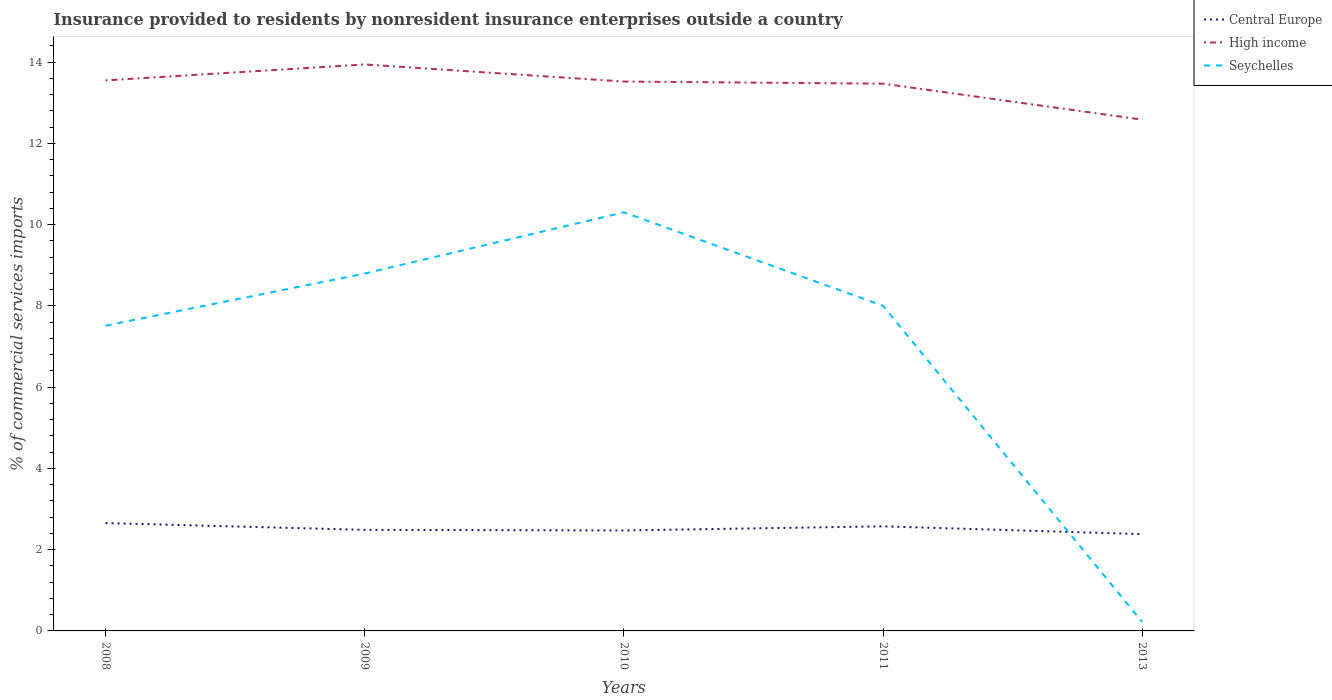Does the line corresponding to High income intersect with the line corresponding to Seychelles?
Your response must be concise. No. Across all years, what is the maximum Insurance provided to residents in Seychelles?
Give a very brief answer. 0.22. In which year was the Insurance provided to residents in Seychelles maximum?
Provide a succinct answer. 2013. What is the total Insurance provided to residents in Central Europe in the graph?
Ensure brevity in your answer.  0.1. What is the difference between the highest and the second highest Insurance provided to residents in Central Europe?
Your response must be concise. 0.27. What is the difference between the highest and the lowest Insurance provided to residents in High income?
Your answer should be compact. 4. How many lines are there?
Your answer should be very brief. 3. How many legend labels are there?
Your answer should be compact. 3. How are the legend labels stacked?
Provide a short and direct response. Vertical. What is the title of the graph?
Offer a terse response. Insurance provided to residents by nonresident insurance enterprises outside a country. What is the label or title of the Y-axis?
Your response must be concise. % of commercial services imports. What is the % of commercial services imports of Central Europe in 2008?
Your answer should be compact. 2.65. What is the % of commercial services imports of High income in 2008?
Make the answer very short. 13.55. What is the % of commercial services imports of Seychelles in 2008?
Offer a terse response. 7.51. What is the % of commercial services imports of Central Europe in 2009?
Offer a very short reply. 2.49. What is the % of commercial services imports of High income in 2009?
Offer a very short reply. 13.94. What is the % of commercial services imports of Seychelles in 2009?
Provide a succinct answer. 8.8. What is the % of commercial services imports of Central Europe in 2010?
Your answer should be compact. 2.47. What is the % of commercial services imports in High income in 2010?
Offer a very short reply. 13.52. What is the % of commercial services imports in Seychelles in 2010?
Your answer should be compact. 10.3. What is the % of commercial services imports in Central Europe in 2011?
Provide a short and direct response. 2.57. What is the % of commercial services imports of High income in 2011?
Provide a succinct answer. 13.47. What is the % of commercial services imports of Seychelles in 2011?
Your response must be concise. 8. What is the % of commercial services imports in Central Europe in 2013?
Ensure brevity in your answer.  2.38. What is the % of commercial services imports in High income in 2013?
Make the answer very short. 12.58. What is the % of commercial services imports in Seychelles in 2013?
Provide a short and direct response. 0.22. Across all years, what is the maximum % of commercial services imports of Central Europe?
Your answer should be compact. 2.65. Across all years, what is the maximum % of commercial services imports of High income?
Make the answer very short. 13.94. Across all years, what is the maximum % of commercial services imports in Seychelles?
Make the answer very short. 10.3. Across all years, what is the minimum % of commercial services imports in Central Europe?
Offer a very short reply. 2.38. Across all years, what is the minimum % of commercial services imports in High income?
Offer a terse response. 12.58. Across all years, what is the minimum % of commercial services imports in Seychelles?
Provide a succinct answer. 0.22. What is the total % of commercial services imports in Central Europe in the graph?
Make the answer very short. 12.57. What is the total % of commercial services imports of High income in the graph?
Keep it short and to the point. 67.06. What is the total % of commercial services imports of Seychelles in the graph?
Ensure brevity in your answer.  34.83. What is the difference between the % of commercial services imports of Central Europe in 2008 and that in 2009?
Provide a succinct answer. 0.17. What is the difference between the % of commercial services imports of High income in 2008 and that in 2009?
Keep it short and to the point. -0.39. What is the difference between the % of commercial services imports in Seychelles in 2008 and that in 2009?
Your answer should be very brief. -1.28. What is the difference between the % of commercial services imports of Central Europe in 2008 and that in 2010?
Ensure brevity in your answer.  0.18. What is the difference between the % of commercial services imports of High income in 2008 and that in 2010?
Keep it short and to the point. 0.03. What is the difference between the % of commercial services imports in Seychelles in 2008 and that in 2010?
Keep it short and to the point. -2.79. What is the difference between the % of commercial services imports of Central Europe in 2008 and that in 2011?
Your response must be concise. 0.08. What is the difference between the % of commercial services imports in High income in 2008 and that in 2011?
Provide a short and direct response. 0.08. What is the difference between the % of commercial services imports of Seychelles in 2008 and that in 2011?
Keep it short and to the point. -0.49. What is the difference between the % of commercial services imports of Central Europe in 2008 and that in 2013?
Provide a succinct answer. 0.27. What is the difference between the % of commercial services imports of High income in 2008 and that in 2013?
Ensure brevity in your answer.  0.97. What is the difference between the % of commercial services imports in Seychelles in 2008 and that in 2013?
Offer a very short reply. 7.29. What is the difference between the % of commercial services imports in Central Europe in 2009 and that in 2010?
Ensure brevity in your answer.  0.01. What is the difference between the % of commercial services imports of High income in 2009 and that in 2010?
Your response must be concise. 0.42. What is the difference between the % of commercial services imports in Seychelles in 2009 and that in 2010?
Your response must be concise. -1.51. What is the difference between the % of commercial services imports in Central Europe in 2009 and that in 2011?
Keep it short and to the point. -0.09. What is the difference between the % of commercial services imports of High income in 2009 and that in 2011?
Your response must be concise. 0.47. What is the difference between the % of commercial services imports in Seychelles in 2009 and that in 2011?
Give a very brief answer. 0.79. What is the difference between the % of commercial services imports of Central Europe in 2009 and that in 2013?
Offer a terse response. 0.1. What is the difference between the % of commercial services imports in High income in 2009 and that in 2013?
Your response must be concise. 1.36. What is the difference between the % of commercial services imports of Seychelles in 2009 and that in 2013?
Your answer should be very brief. 8.57. What is the difference between the % of commercial services imports of Central Europe in 2010 and that in 2011?
Your answer should be very brief. -0.1. What is the difference between the % of commercial services imports in High income in 2010 and that in 2011?
Provide a short and direct response. 0.05. What is the difference between the % of commercial services imports of Seychelles in 2010 and that in 2011?
Give a very brief answer. 2.3. What is the difference between the % of commercial services imports in Central Europe in 2010 and that in 2013?
Offer a terse response. 0.09. What is the difference between the % of commercial services imports of Seychelles in 2010 and that in 2013?
Give a very brief answer. 10.08. What is the difference between the % of commercial services imports of Central Europe in 2011 and that in 2013?
Provide a succinct answer. 0.19. What is the difference between the % of commercial services imports of High income in 2011 and that in 2013?
Your response must be concise. 0.88. What is the difference between the % of commercial services imports of Seychelles in 2011 and that in 2013?
Keep it short and to the point. 7.78. What is the difference between the % of commercial services imports in Central Europe in 2008 and the % of commercial services imports in High income in 2009?
Ensure brevity in your answer.  -11.29. What is the difference between the % of commercial services imports in Central Europe in 2008 and the % of commercial services imports in Seychelles in 2009?
Your answer should be very brief. -6.14. What is the difference between the % of commercial services imports in High income in 2008 and the % of commercial services imports in Seychelles in 2009?
Keep it short and to the point. 4.75. What is the difference between the % of commercial services imports in Central Europe in 2008 and the % of commercial services imports in High income in 2010?
Offer a very short reply. -10.87. What is the difference between the % of commercial services imports of Central Europe in 2008 and the % of commercial services imports of Seychelles in 2010?
Offer a terse response. -7.65. What is the difference between the % of commercial services imports of High income in 2008 and the % of commercial services imports of Seychelles in 2010?
Give a very brief answer. 3.25. What is the difference between the % of commercial services imports of Central Europe in 2008 and the % of commercial services imports of High income in 2011?
Provide a succinct answer. -10.81. What is the difference between the % of commercial services imports of Central Europe in 2008 and the % of commercial services imports of Seychelles in 2011?
Your response must be concise. -5.35. What is the difference between the % of commercial services imports in High income in 2008 and the % of commercial services imports in Seychelles in 2011?
Keep it short and to the point. 5.55. What is the difference between the % of commercial services imports in Central Europe in 2008 and the % of commercial services imports in High income in 2013?
Provide a succinct answer. -9.93. What is the difference between the % of commercial services imports of Central Europe in 2008 and the % of commercial services imports of Seychelles in 2013?
Offer a terse response. 2.43. What is the difference between the % of commercial services imports in High income in 2008 and the % of commercial services imports in Seychelles in 2013?
Ensure brevity in your answer.  13.33. What is the difference between the % of commercial services imports of Central Europe in 2009 and the % of commercial services imports of High income in 2010?
Make the answer very short. -11.03. What is the difference between the % of commercial services imports of Central Europe in 2009 and the % of commercial services imports of Seychelles in 2010?
Your response must be concise. -7.81. What is the difference between the % of commercial services imports in High income in 2009 and the % of commercial services imports in Seychelles in 2010?
Your response must be concise. 3.64. What is the difference between the % of commercial services imports in Central Europe in 2009 and the % of commercial services imports in High income in 2011?
Ensure brevity in your answer.  -10.98. What is the difference between the % of commercial services imports of Central Europe in 2009 and the % of commercial services imports of Seychelles in 2011?
Make the answer very short. -5.51. What is the difference between the % of commercial services imports in High income in 2009 and the % of commercial services imports in Seychelles in 2011?
Offer a very short reply. 5.94. What is the difference between the % of commercial services imports in Central Europe in 2009 and the % of commercial services imports in High income in 2013?
Offer a very short reply. -10.1. What is the difference between the % of commercial services imports of Central Europe in 2009 and the % of commercial services imports of Seychelles in 2013?
Ensure brevity in your answer.  2.27. What is the difference between the % of commercial services imports in High income in 2009 and the % of commercial services imports in Seychelles in 2013?
Provide a succinct answer. 13.72. What is the difference between the % of commercial services imports in Central Europe in 2010 and the % of commercial services imports in High income in 2011?
Your response must be concise. -11. What is the difference between the % of commercial services imports in Central Europe in 2010 and the % of commercial services imports in Seychelles in 2011?
Your answer should be compact. -5.53. What is the difference between the % of commercial services imports of High income in 2010 and the % of commercial services imports of Seychelles in 2011?
Offer a very short reply. 5.52. What is the difference between the % of commercial services imports in Central Europe in 2010 and the % of commercial services imports in High income in 2013?
Provide a succinct answer. -10.11. What is the difference between the % of commercial services imports of Central Europe in 2010 and the % of commercial services imports of Seychelles in 2013?
Your answer should be very brief. 2.25. What is the difference between the % of commercial services imports of High income in 2010 and the % of commercial services imports of Seychelles in 2013?
Your answer should be compact. 13.3. What is the difference between the % of commercial services imports in Central Europe in 2011 and the % of commercial services imports in High income in 2013?
Your answer should be very brief. -10.01. What is the difference between the % of commercial services imports of Central Europe in 2011 and the % of commercial services imports of Seychelles in 2013?
Offer a very short reply. 2.35. What is the difference between the % of commercial services imports of High income in 2011 and the % of commercial services imports of Seychelles in 2013?
Offer a terse response. 13.25. What is the average % of commercial services imports in Central Europe per year?
Your response must be concise. 2.51. What is the average % of commercial services imports of High income per year?
Your answer should be compact. 13.41. What is the average % of commercial services imports in Seychelles per year?
Keep it short and to the point. 6.97. In the year 2008, what is the difference between the % of commercial services imports in Central Europe and % of commercial services imports in High income?
Give a very brief answer. -10.89. In the year 2008, what is the difference between the % of commercial services imports in Central Europe and % of commercial services imports in Seychelles?
Your answer should be compact. -4.86. In the year 2008, what is the difference between the % of commercial services imports of High income and % of commercial services imports of Seychelles?
Make the answer very short. 6.04. In the year 2009, what is the difference between the % of commercial services imports of Central Europe and % of commercial services imports of High income?
Your response must be concise. -11.45. In the year 2009, what is the difference between the % of commercial services imports in Central Europe and % of commercial services imports in Seychelles?
Keep it short and to the point. -6.31. In the year 2009, what is the difference between the % of commercial services imports of High income and % of commercial services imports of Seychelles?
Your answer should be very brief. 5.15. In the year 2010, what is the difference between the % of commercial services imports of Central Europe and % of commercial services imports of High income?
Offer a terse response. -11.05. In the year 2010, what is the difference between the % of commercial services imports of Central Europe and % of commercial services imports of Seychelles?
Ensure brevity in your answer.  -7.83. In the year 2010, what is the difference between the % of commercial services imports in High income and % of commercial services imports in Seychelles?
Your answer should be very brief. 3.22. In the year 2011, what is the difference between the % of commercial services imports of Central Europe and % of commercial services imports of High income?
Give a very brief answer. -10.89. In the year 2011, what is the difference between the % of commercial services imports in Central Europe and % of commercial services imports in Seychelles?
Offer a very short reply. -5.43. In the year 2011, what is the difference between the % of commercial services imports in High income and % of commercial services imports in Seychelles?
Keep it short and to the point. 5.47. In the year 2013, what is the difference between the % of commercial services imports of Central Europe and % of commercial services imports of High income?
Offer a terse response. -10.2. In the year 2013, what is the difference between the % of commercial services imports in Central Europe and % of commercial services imports in Seychelles?
Give a very brief answer. 2.16. In the year 2013, what is the difference between the % of commercial services imports of High income and % of commercial services imports of Seychelles?
Offer a very short reply. 12.36. What is the ratio of the % of commercial services imports of Central Europe in 2008 to that in 2009?
Provide a short and direct response. 1.07. What is the ratio of the % of commercial services imports in High income in 2008 to that in 2009?
Your answer should be compact. 0.97. What is the ratio of the % of commercial services imports of Seychelles in 2008 to that in 2009?
Your answer should be compact. 0.85. What is the ratio of the % of commercial services imports of Central Europe in 2008 to that in 2010?
Offer a very short reply. 1.07. What is the ratio of the % of commercial services imports in High income in 2008 to that in 2010?
Your response must be concise. 1. What is the ratio of the % of commercial services imports in Seychelles in 2008 to that in 2010?
Provide a short and direct response. 0.73. What is the ratio of the % of commercial services imports in Central Europe in 2008 to that in 2011?
Provide a short and direct response. 1.03. What is the ratio of the % of commercial services imports in Seychelles in 2008 to that in 2011?
Provide a succinct answer. 0.94. What is the ratio of the % of commercial services imports in Central Europe in 2008 to that in 2013?
Your answer should be compact. 1.11. What is the ratio of the % of commercial services imports in High income in 2008 to that in 2013?
Your answer should be compact. 1.08. What is the ratio of the % of commercial services imports of Seychelles in 2008 to that in 2013?
Offer a terse response. 34.03. What is the ratio of the % of commercial services imports in Central Europe in 2009 to that in 2010?
Give a very brief answer. 1.01. What is the ratio of the % of commercial services imports of High income in 2009 to that in 2010?
Your response must be concise. 1.03. What is the ratio of the % of commercial services imports in Seychelles in 2009 to that in 2010?
Offer a terse response. 0.85. What is the ratio of the % of commercial services imports of Central Europe in 2009 to that in 2011?
Offer a very short reply. 0.97. What is the ratio of the % of commercial services imports in High income in 2009 to that in 2011?
Ensure brevity in your answer.  1.04. What is the ratio of the % of commercial services imports of Seychelles in 2009 to that in 2011?
Offer a terse response. 1.1. What is the ratio of the % of commercial services imports of Central Europe in 2009 to that in 2013?
Keep it short and to the point. 1.04. What is the ratio of the % of commercial services imports in High income in 2009 to that in 2013?
Your response must be concise. 1.11. What is the ratio of the % of commercial services imports in Seychelles in 2009 to that in 2013?
Your answer should be compact. 39.84. What is the ratio of the % of commercial services imports in Central Europe in 2010 to that in 2011?
Your answer should be very brief. 0.96. What is the ratio of the % of commercial services imports of High income in 2010 to that in 2011?
Your answer should be very brief. 1. What is the ratio of the % of commercial services imports in Seychelles in 2010 to that in 2011?
Give a very brief answer. 1.29. What is the ratio of the % of commercial services imports of Central Europe in 2010 to that in 2013?
Give a very brief answer. 1.04. What is the ratio of the % of commercial services imports of High income in 2010 to that in 2013?
Your response must be concise. 1.07. What is the ratio of the % of commercial services imports of Seychelles in 2010 to that in 2013?
Give a very brief answer. 46.66. What is the ratio of the % of commercial services imports in Central Europe in 2011 to that in 2013?
Provide a short and direct response. 1.08. What is the ratio of the % of commercial services imports in High income in 2011 to that in 2013?
Provide a short and direct response. 1.07. What is the ratio of the % of commercial services imports in Seychelles in 2011 to that in 2013?
Your answer should be very brief. 36.24. What is the difference between the highest and the second highest % of commercial services imports of Central Europe?
Provide a short and direct response. 0.08. What is the difference between the highest and the second highest % of commercial services imports of High income?
Make the answer very short. 0.39. What is the difference between the highest and the second highest % of commercial services imports in Seychelles?
Keep it short and to the point. 1.51. What is the difference between the highest and the lowest % of commercial services imports in Central Europe?
Ensure brevity in your answer.  0.27. What is the difference between the highest and the lowest % of commercial services imports in High income?
Give a very brief answer. 1.36. What is the difference between the highest and the lowest % of commercial services imports of Seychelles?
Your answer should be very brief. 10.08. 